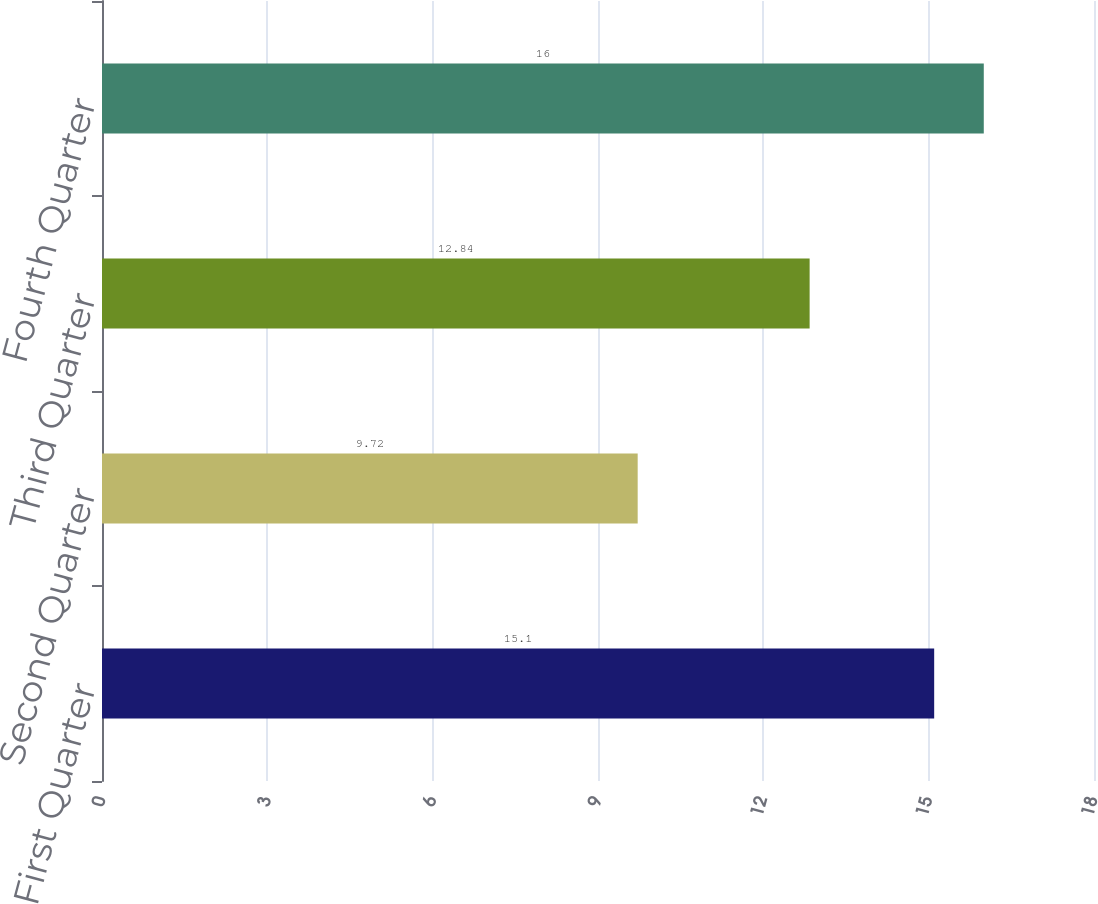Convert chart. <chart><loc_0><loc_0><loc_500><loc_500><bar_chart><fcel>First Quarter<fcel>Second Quarter<fcel>Third Quarter<fcel>Fourth Quarter<nl><fcel>15.1<fcel>9.72<fcel>12.84<fcel>16<nl></chart> 